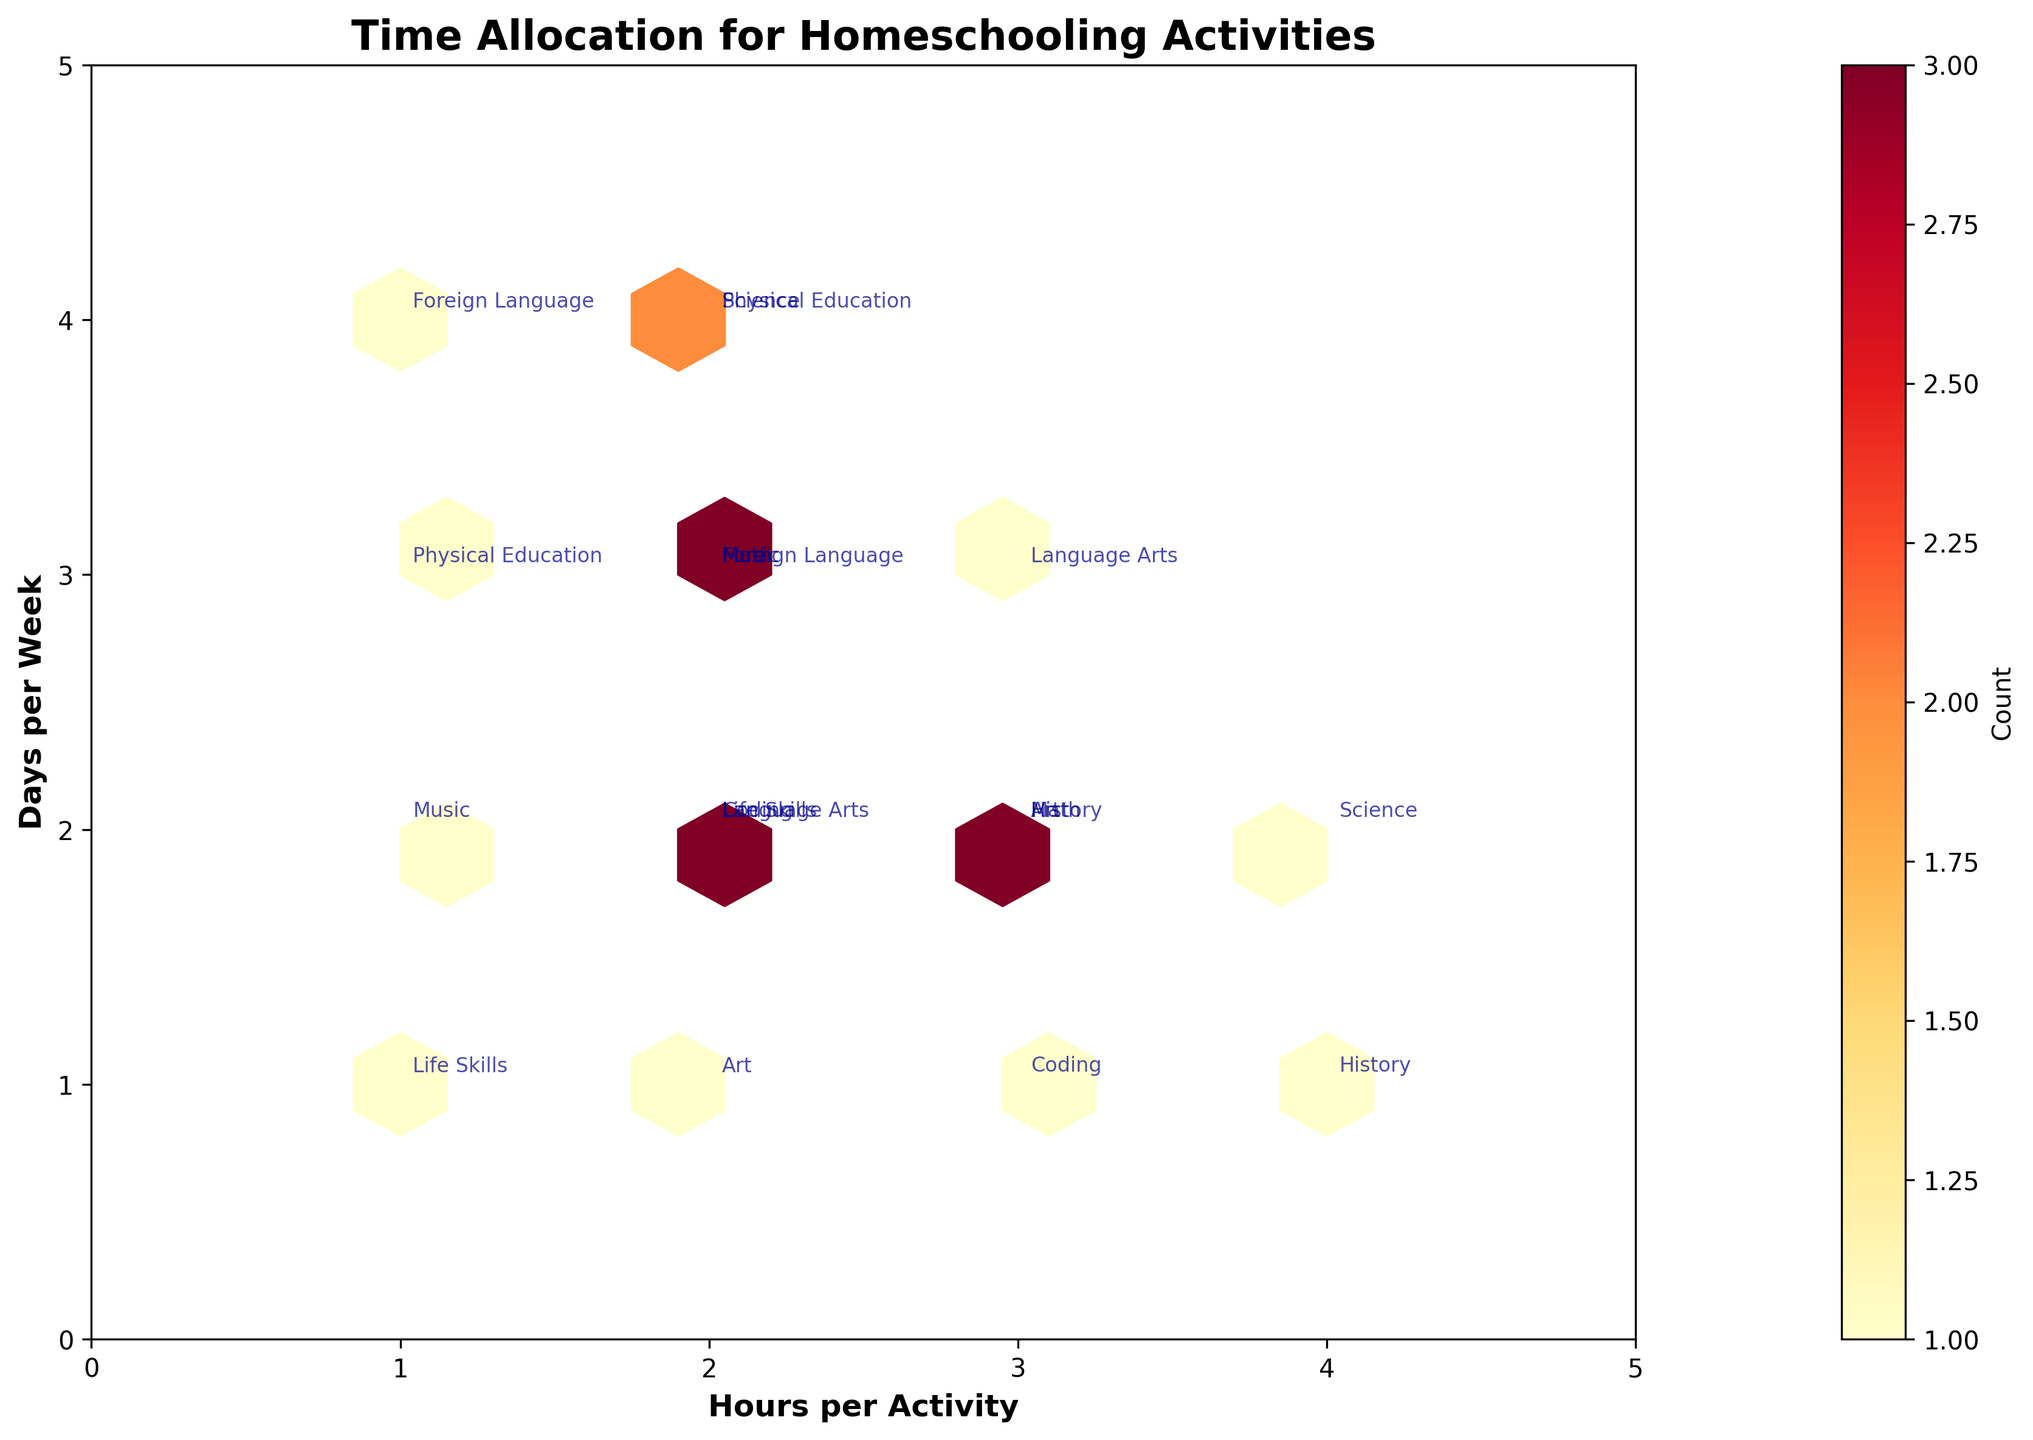What is the title of the figure? The title is usually displayed at the top of the plot and provides an overview of what the plot represents. Look above the chart's area.
Answer: Time Allocation for Homeschooling Activities How many hours are allocated on average for Group Discussion in Language Arts? Identify the point for Group Discussion in Language Arts on the plot. The x-axis represents hours, and find the average or exact value at that point.
Answer: 2 hours Which subjects have the highest allocation in terms of days per week? Locate the points on the plot where the y-axis (Days per Week) is highest. Identify the subject labels corresponding to these points.
Answer: Foreign Language, Conversation Practice and Physical Education, Outdoor Activities What is the relationship between hours spent on Documentaries in History and Fitness Videos in Physical Education? Find the points on the plot for both Documentaries in History and Fitness Videos in Physical Education. The x-axis shows the hours. Compare these two values.
Answer: Documentaries (3 hours) is greater than Fitness Videos (1 hour) How many days per week are allocated to Instrument Practice in Music and Writing Exercises in Language Arts combined? Locate the data points for Instrument Practice in Music and Writing Exercises in Language Arts. Add the days from the y-axis for both points.
Answer: 5 days (3 + 2) What is the color indicating the highest count of activities on the Hexbin plot? Look at the color bar on the plot, which shows the gradient of colors used. Identify the color representing the highest value.
Answer: Dark red How is the distribution of time in terms of hours for Coding activities? Identify the points for Coding activities (Online Tutorials, Practical Projects) on the plot. Observe how these points are distributed along the x-axis (Hours).
Answer: Mostly between 2 to 3 hours Which subject and activity combination appears most frequently on the plot? Check the hexagons for the highest density. The color on the plot shows the frequency of data points. Identify the subject and activity label most common in that region.
Answer: Visual indicators suggest combinations like Math, Science, or Language Arts with specific activities could be frequent but exact details would need closer examination Which subject activities fall into the 3-hour per activity range on the x-axis? Locate all points on the plot that align with the 3-hour mark on the x-axis. Identify the subject and activities associated with these points.
Answer: Math, Hands-on Activities, Language Arts, Writing Exercises, History, Documentaries, Art, Creative Projects, Coding, Practical Projects How can we interpret the overall distribution of days per week for homeschooling activities? Examine the y-axis, noting the spread of data points from the minimum to the maximum value. Look for clustering or spread patterns indicating how many subjects fall into certain day ranges.
Answer: Activities are spread between 1 to 4 days per week, with some clustering around 2-3 days 